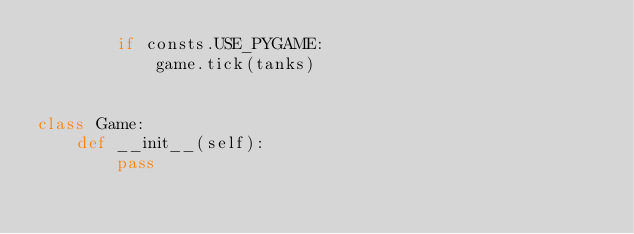<code> <loc_0><loc_0><loc_500><loc_500><_Python_>        if consts.USE_PYGAME:
            game.tick(tanks)


class Game:
    def __init__(self):
        pass

</code> 